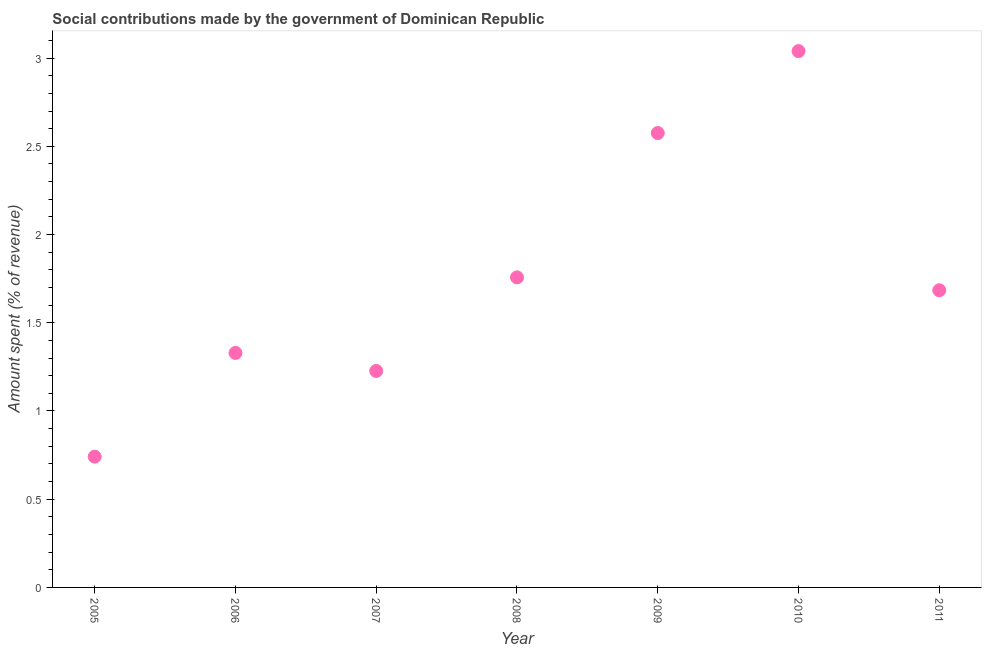What is the amount spent in making social contributions in 2010?
Your answer should be very brief. 3.04. Across all years, what is the maximum amount spent in making social contributions?
Your response must be concise. 3.04. Across all years, what is the minimum amount spent in making social contributions?
Provide a short and direct response. 0.74. In which year was the amount spent in making social contributions minimum?
Your answer should be very brief. 2005. What is the sum of the amount spent in making social contributions?
Provide a succinct answer. 12.35. What is the difference between the amount spent in making social contributions in 2009 and 2011?
Provide a succinct answer. 0.89. What is the average amount spent in making social contributions per year?
Your answer should be compact. 1.76. What is the median amount spent in making social contributions?
Make the answer very short. 1.68. In how many years, is the amount spent in making social contributions greater than 0.5 %?
Keep it short and to the point. 7. What is the ratio of the amount spent in making social contributions in 2005 to that in 2007?
Provide a short and direct response. 0.6. What is the difference between the highest and the second highest amount spent in making social contributions?
Offer a very short reply. 0.46. Is the sum of the amount spent in making social contributions in 2010 and 2011 greater than the maximum amount spent in making social contributions across all years?
Ensure brevity in your answer.  Yes. What is the difference between the highest and the lowest amount spent in making social contributions?
Offer a very short reply. 2.3. Are the values on the major ticks of Y-axis written in scientific E-notation?
Give a very brief answer. No. Does the graph contain any zero values?
Your answer should be very brief. No. What is the title of the graph?
Your answer should be very brief. Social contributions made by the government of Dominican Republic. What is the label or title of the Y-axis?
Ensure brevity in your answer.  Amount spent (% of revenue). What is the Amount spent (% of revenue) in 2005?
Give a very brief answer. 0.74. What is the Amount spent (% of revenue) in 2006?
Your response must be concise. 1.33. What is the Amount spent (% of revenue) in 2007?
Ensure brevity in your answer.  1.23. What is the Amount spent (% of revenue) in 2008?
Provide a succinct answer. 1.76. What is the Amount spent (% of revenue) in 2009?
Give a very brief answer. 2.58. What is the Amount spent (% of revenue) in 2010?
Your answer should be compact. 3.04. What is the Amount spent (% of revenue) in 2011?
Make the answer very short. 1.68. What is the difference between the Amount spent (% of revenue) in 2005 and 2006?
Your answer should be very brief. -0.59. What is the difference between the Amount spent (% of revenue) in 2005 and 2007?
Give a very brief answer. -0.49. What is the difference between the Amount spent (% of revenue) in 2005 and 2008?
Provide a short and direct response. -1.02. What is the difference between the Amount spent (% of revenue) in 2005 and 2009?
Provide a short and direct response. -1.83. What is the difference between the Amount spent (% of revenue) in 2005 and 2010?
Offer a very short reply. -2.3. What is the difference between the Amount spent (% of revenue) in 2005 and 2011?
Give a very brief answer. -0.94. What is the difference between the Amount spent (% of revenue) in 2006 and 2007?
Give a very brief answer. 0.1. What is the difference between the Amount spent (% of revenue) in 2006 and 2008?
Ensure brevity in your answer.  -0.43. What is the difference between the Amount spent (% of revenue) in 2006 and 2009?
Ensure brevity in your answer.  -1.25. What is the difference between the Amount spent (% of revenue) in 2006 and 2010?
Offer a very short reply. -1.71. What is the difference between the Amount spent (% of revenue) in 2006 and 2011?
Ensure brevity in your answer.  -0.36. What is the difference between the Amount spent (% of revenue) in 2007 and 2008?
Give a very brief answer. -0.53. What is the difference between the Amount spent (% of revenue) in 2007 and 2009?
Ensure brevity in your answer.  -1.35. What is the difference between the Amount spent (% of revenue) in 2007 and 2010?
Your response must be concise. -1.81. What is the difference between the Amount spent (% of revenue) in 2007 and 2011?
Make the answer very short. -0.46. What is the difference between the Amount spent (% of revenue) in 2008 and 2009?
Make the answer very short. -0.82. What is the difference between the Amount spent (% of revenue) in 2008 and 2010?
Offer a very short reply. -1.28. What is the difference between the Amount spent (% of revenue) in 2008 and 2011?
Your answer should be compact. 0.07. What is the difference between the Amount spent (% of revenue) in 2009 and 2010?
Provide a succinct answer. -0.46. What is the difference between the Amount spent (% of revenue) in 2009 and 2011?
Provide a succinct answer. 0.89. What is the difference between the Amount spent (% of revenue) in 2010 and 2011?
Provide a short and direct response. 1.36. What is the ratio of the Amount spent (% of revenue) in 2005 to that in 2006?
Provide a succinct answer. 0.56. What is the ratio of the Amount spent (% of revenue) in 2005 to that in 2007?
Your answer should be very brief. 0.6. What is the ratio of the Amount spent (% of revenue) in 2005 to that in 2008?
Provide a short and direct response. 0.42. What is the ratio of the Amount spent (% of revenue) in 2005 to that in 2009?
Offer a terse response. 0.29. What is the ratio of the Amount spent (% of revenue) in 2005 to that in 2010?
Make the answer very short. 0.24. What is the ratio of the Amount spent (% of revenue) in 2005 to that in 2011?
Your answer should be compact. 0.44. What is the ratio of the Amount spent (% of revenue) in 2006 to that in 2007?
Offer a very short reply. 1.08. What is the ratio of the Amount spent (% of revenue) in 2006 to that in 2008?
Provide a succinct answer. 0.76. What is the ratio of the Amount spent (% of revenue) in 2006 to that in 2009?
Give a very brief answer. 0.52. What is the ratio of the Amount spent (% of revenue) in 2006 to that in 2010?
Give a very brief answer. 0.44. What is the ratio of the Amount spent (% of revenue) in 2006 to that in 2011?
Your response must be concise. 0.79. What is the ratio of the Amount spent (% of revenue) in 2007 to that in 2008?
Your answer should be compact. 0.7. What is the ratio of the Amount spent (% of revenue) in 2007 to that in 2009?
Your answer should be compact. 0.48. What is the ratio of the Amount spent (% of revenue) in 2007 to that in 2010?
Your answer should be very brief. 0.4. What is the ratio of the Amount spent (% of revenue) in 2007 to that in 2011?
Your answer should be compact. 0.73. What is the ratio of the Amount spent (% of revenue) in 2008 to that in 2009?
Offer a terse response. 0.68. What is the ratio of the Amount spent (% of revenue) in 2008 to that in 2010?
Your answer should be compact. 0.58. What is the ratio of the Amount spent (% of revenue) in 2008 to that in 2011?
Your answer should be compact. 1.04. What is the ratio of the Amount spent (% of revenue) in 2009 to that in 2010?
Offer a very short reply. 0.85. What is the ratio of the Amount spent (% of revenue) in 2009 to that in 2011?
Keep it short and to the point. 1.53. What is the ratio of the Amount spent (% of revenue) in 2010 to that in 2011?
Ensure brevity in your answer.  1.8. 